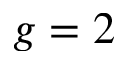<formula> <loc_0><loc_0><loc_500><loc_500>g = 2</formula> 